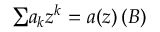Convert formula to latex. <formula><loc_0><loc_0><loc_500><loc_500>{ \sum } a _ { k } z ^ { k } = a ( z ) \, ( B )</formula> 